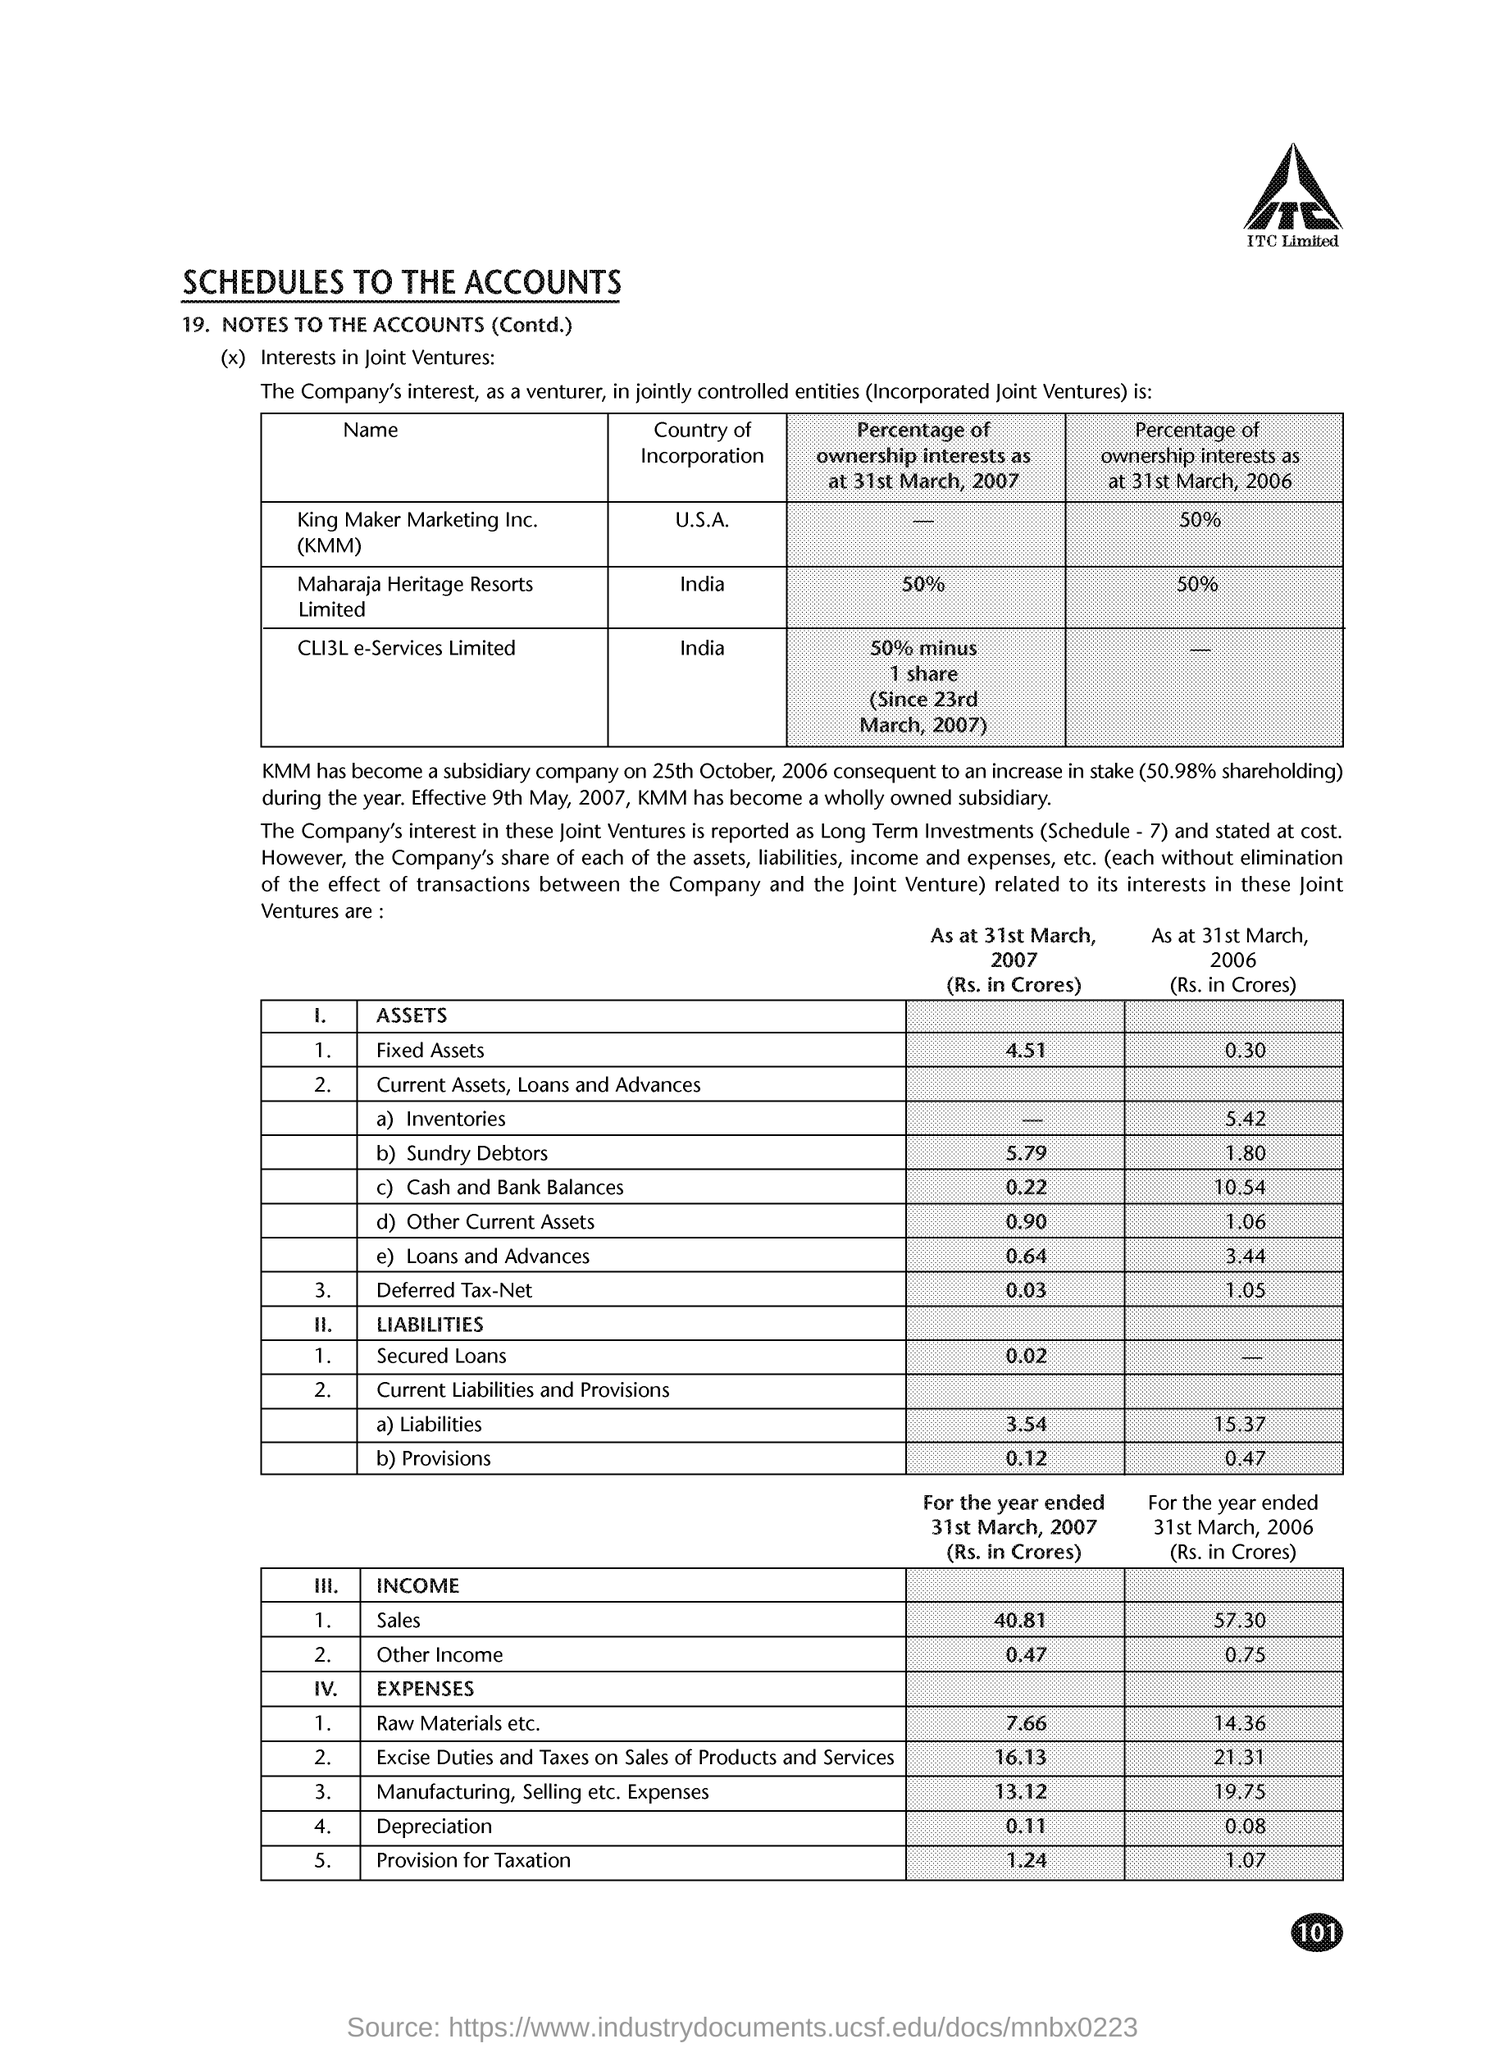How much is the fixed assets as at 31st march 2007 (rs in crores)?
Your answer should be very brief. 4.51. Which country of incorporation does maharaja heritage resorts limited has ?
Offer a very short reply. India. What is the percentage of ownership interests as at 31st march, 2006 kmm has
Your answer should be very brief. 50%. When did kmm has become a subsidiary company consequent to an increase in stake ?
Your answer should be compact. 25th october ,2006. Which country of incorporation does kmm has ?
Provide a succinct answer. U.S.A. What is the expenses of raw materials etc for the year ended 31st march , 2007(rs in crores )?
Offer a very short reply. 7.66. What is the expenses of raw materials etc for the year ended 31st march , 2006(rs in crores )?
Provide a succinct answer. 14.36. 